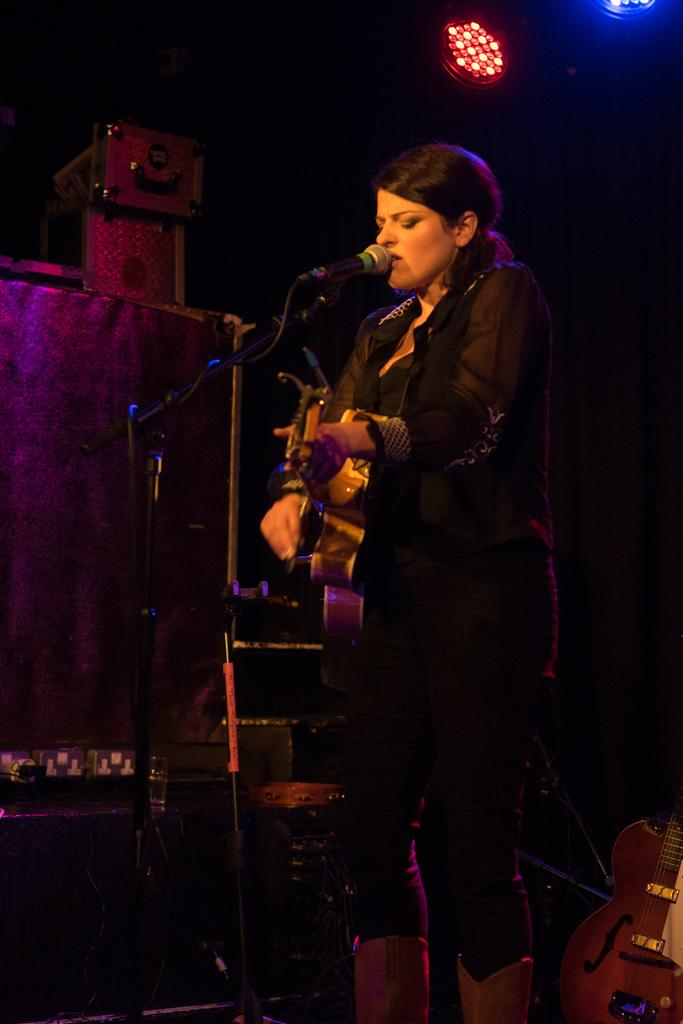What is the lady in the image doing? The lady is playing the guitar and singing. What is the lady wearing in the image? The lady is wearing a black dress. What instrument is the lady holding in the image? The lady is holding a guitar. What object is in front of the lady? There is a microphone in front of the lady. What can be seen in the background of the image? There are lights in the background of the image. Is there another guitar visible in the image? Yes, there is a guitar on the floor. What type of poison is the lady using to enhance her singing voice in the image? There is no mention of poison in the image, and the lady is not using any substance to enhance her singing voice. 